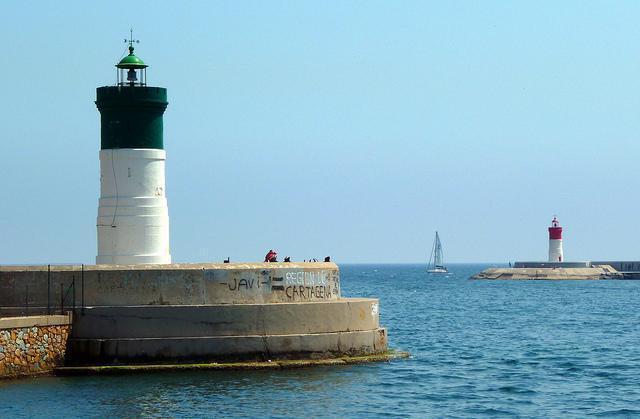How many lighthouses do you see?
Give a very brief answer. 2. How many birds are there?
Give a very brief answer. 0. 